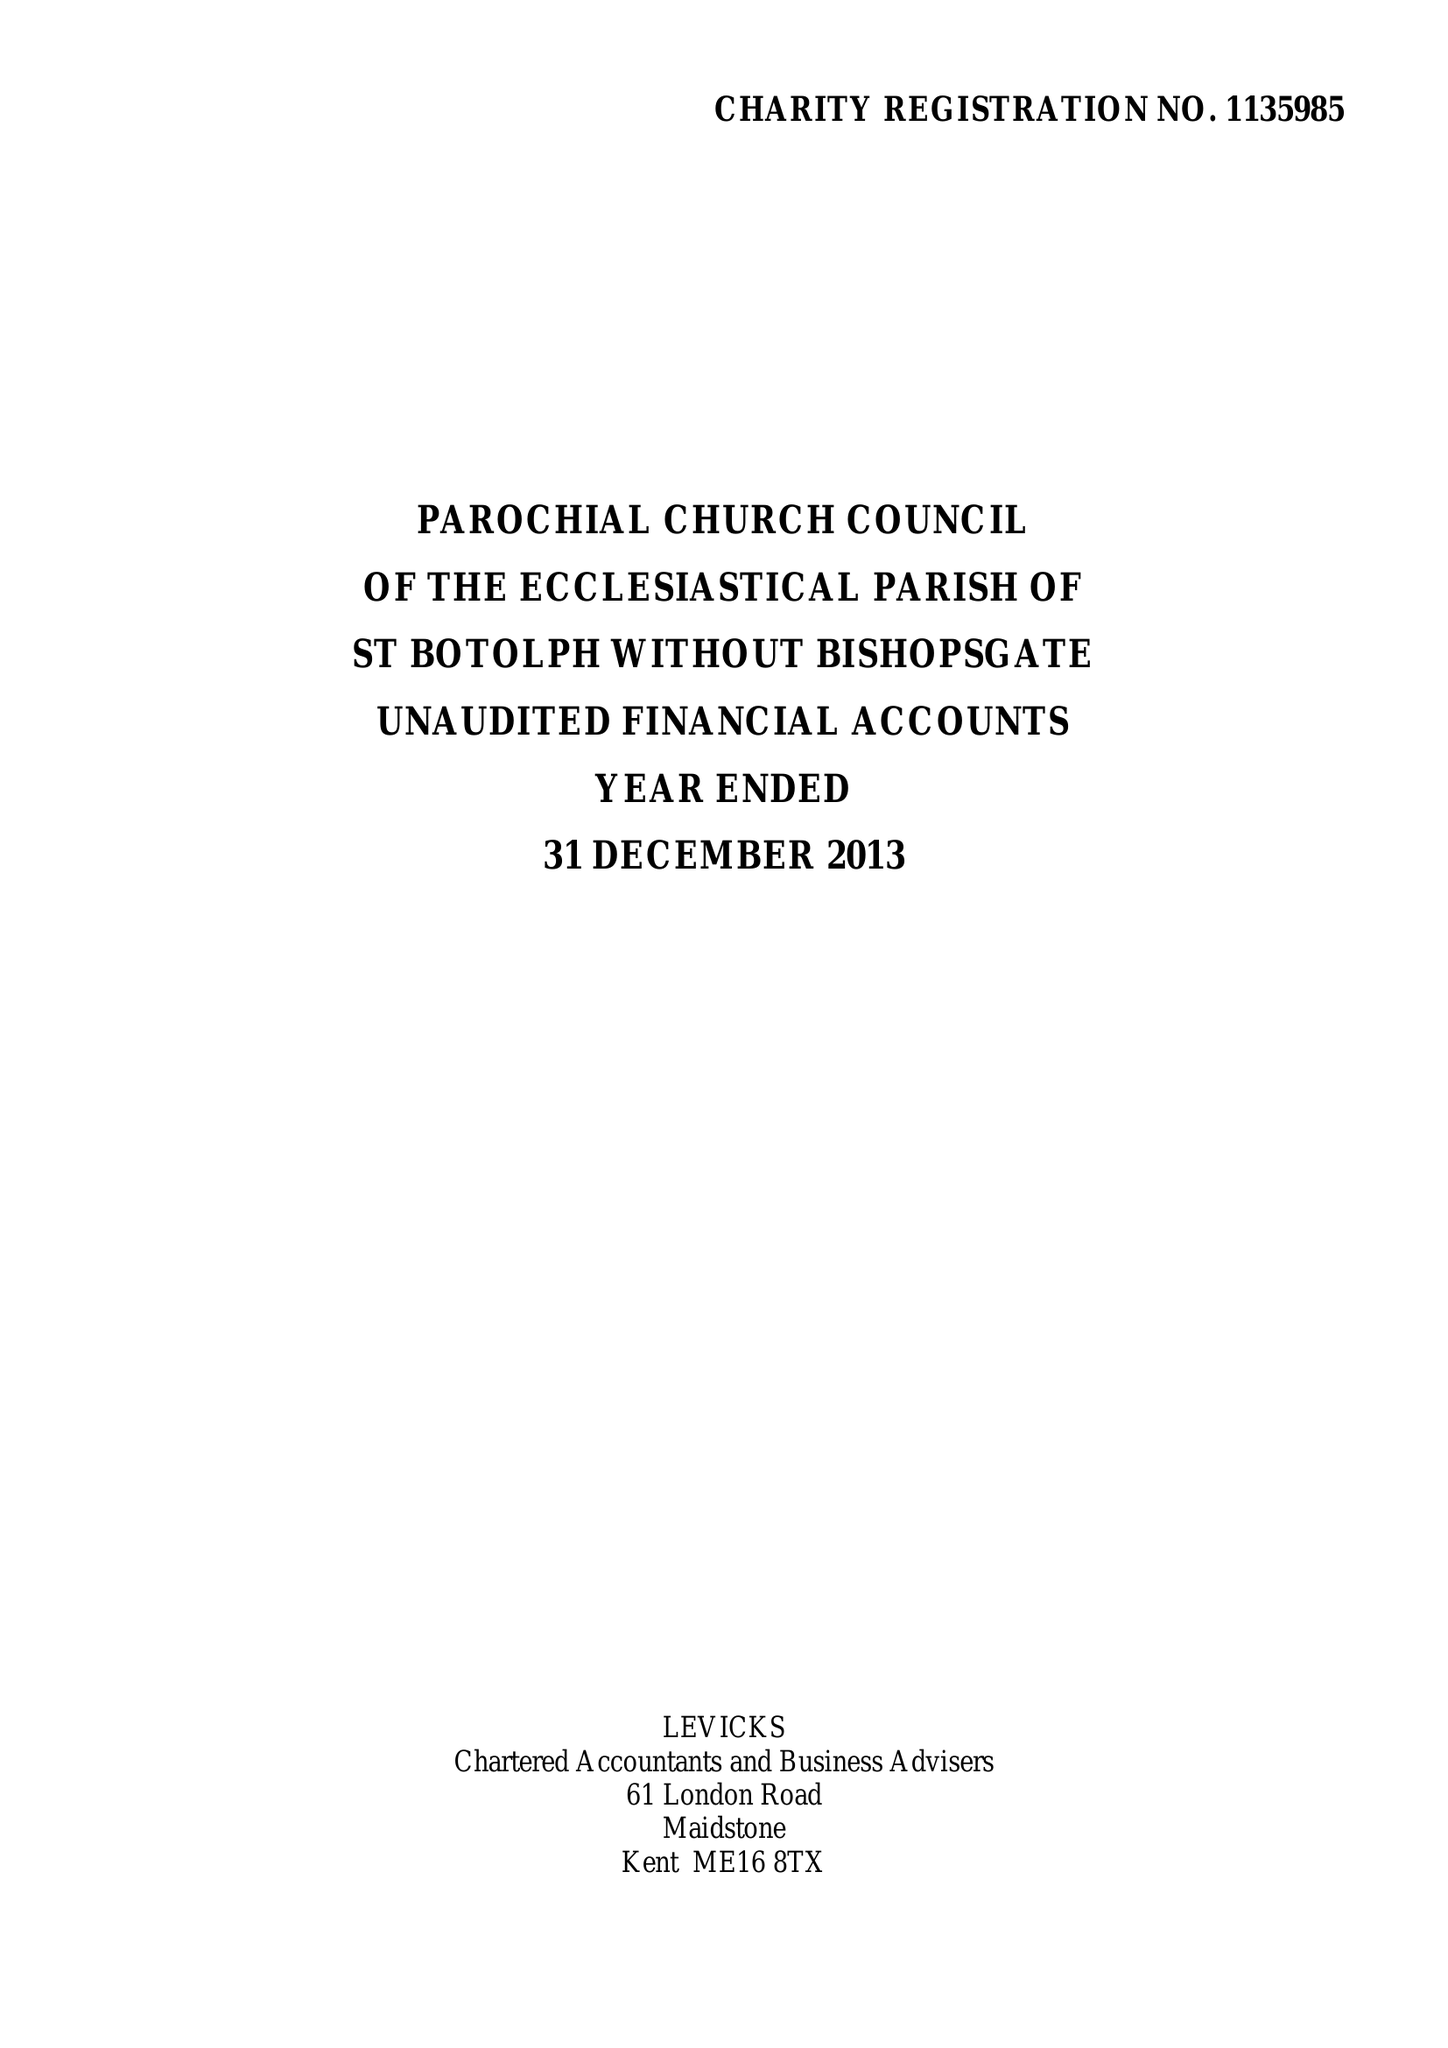What is the value for the address__postcode?
Answer the question using a single word or phrase. EC2M 3TL 